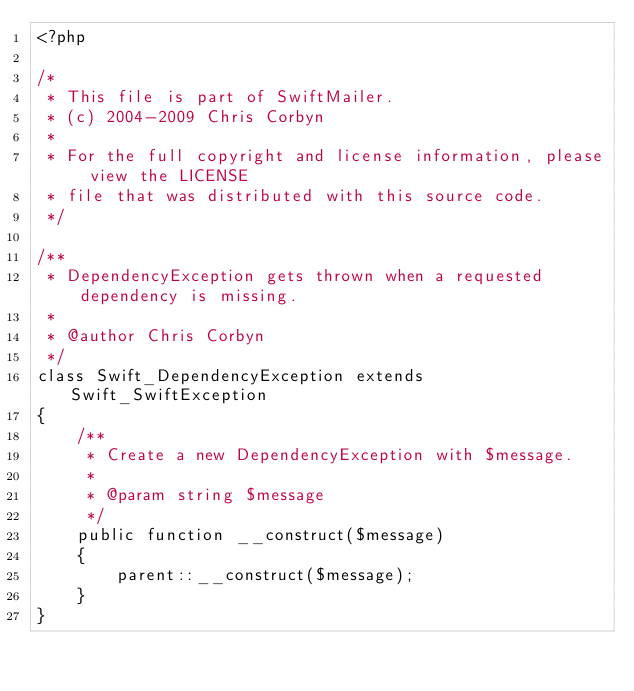Convert code to text. <code><loc_0><loc_0><loc_500><loc_500><_PHP_><?php

/*
 * This file is part of SwiftMailer.
 * (c) 2004-2009 Chris Corbyn
 *
 * For the full copyright and license information, please view the LICENSE
 * file that was distributed with this source code.
 */

/**
 * DependencyException gets thrown when a requested dependency is missing.
 *
 * @author Chris Corbyn
 */
class Swift_DependencyException extends Swift_SwiftException
{
    /**
     * Create a new DependencyException with $message.
     *
     * @param string $message
     */
    public function __construct($message)
    {
        parent::__construct($message);
    }
}
</code> 